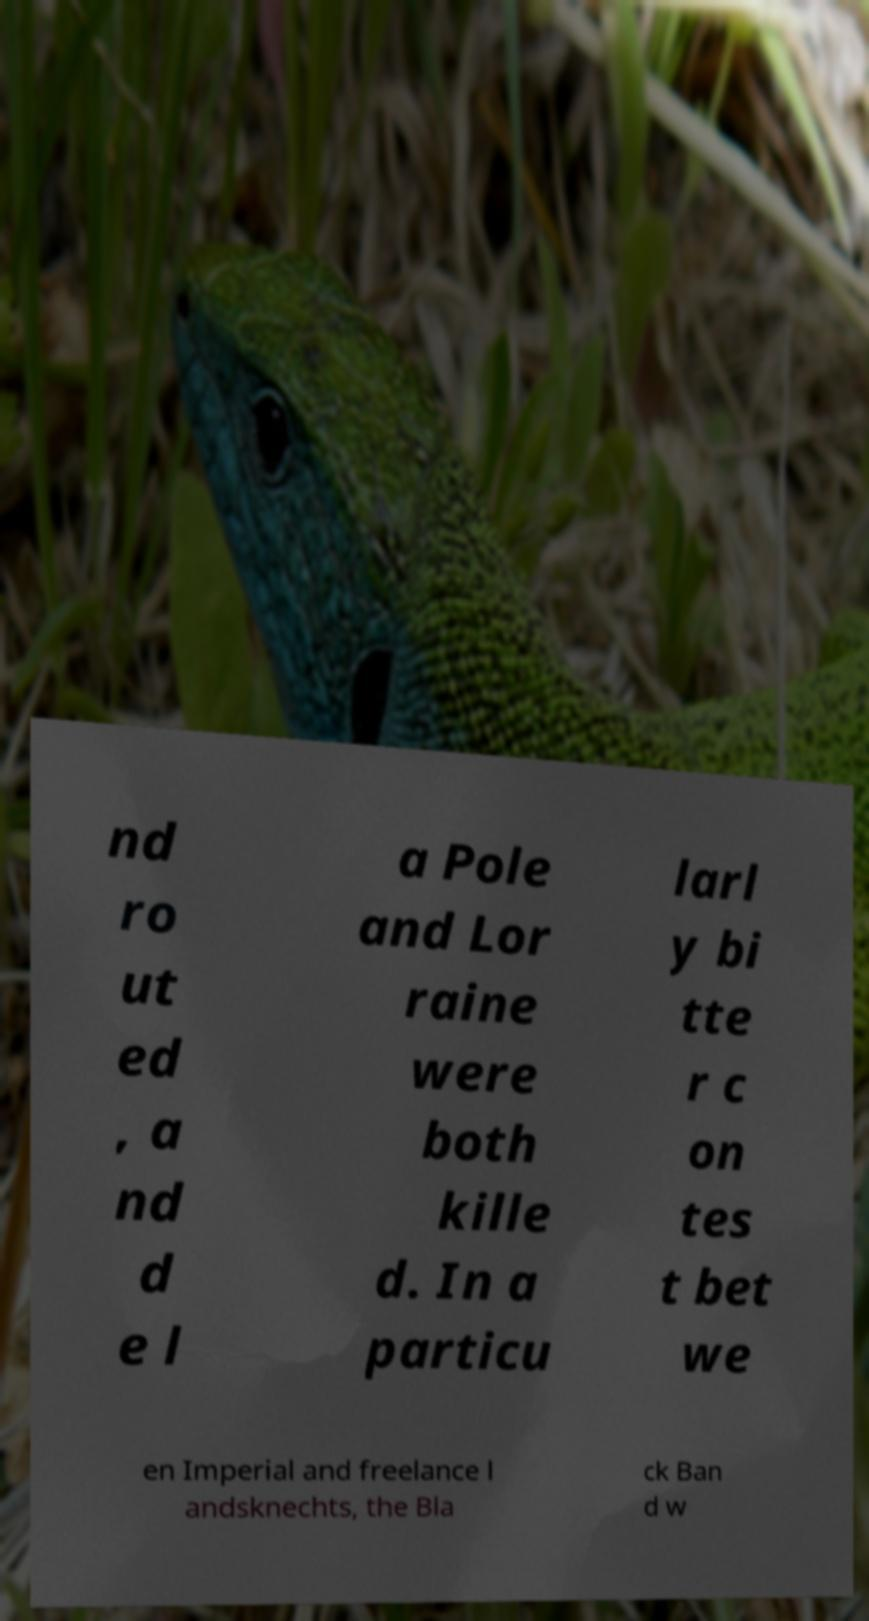Can you read and provide the text displayed in the image?This photo seems to have some interesting text. Can you extract and type it out for me? nd ro ut ed , a nd d e l a Pole and Lor raine were both kille d. In a particu larl y bi tte r c on tes t bet we en Imperial and freelance l andsknechts, the Bla ck Ban d w 